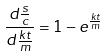<formula> <loc_0><loc_0><loc_500><loc_500>\frac { d \frac { s } { c } } { d \frac { k t } { m } } = 1 - e ^ { \frac { k t } { m } }</formula> 